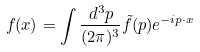<formula> <loc_0><loc_0><loc_500><loc_500>f ( x ) = \int \frac { d ^ { 3 } p } { ( 2 \pi ) ^ { 3 } } \tilde { f } ( p ) e ^ { - i p \cdot x }</formula> 